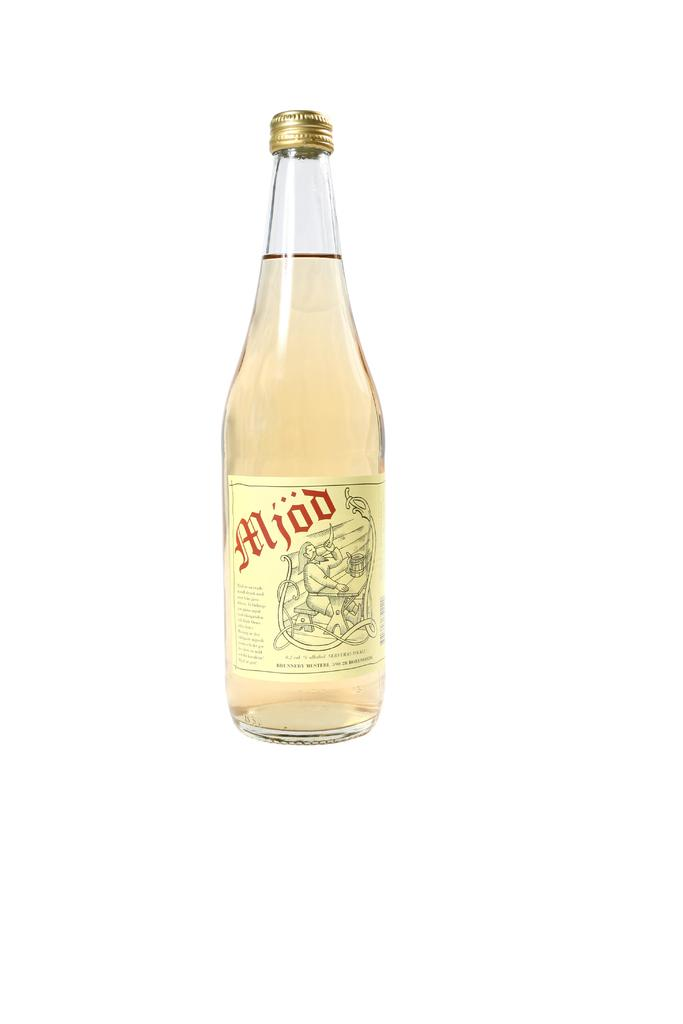<image>
Create a compact narrative representing the image presented. A bottle of light yellow Mjod with the cap closed. 